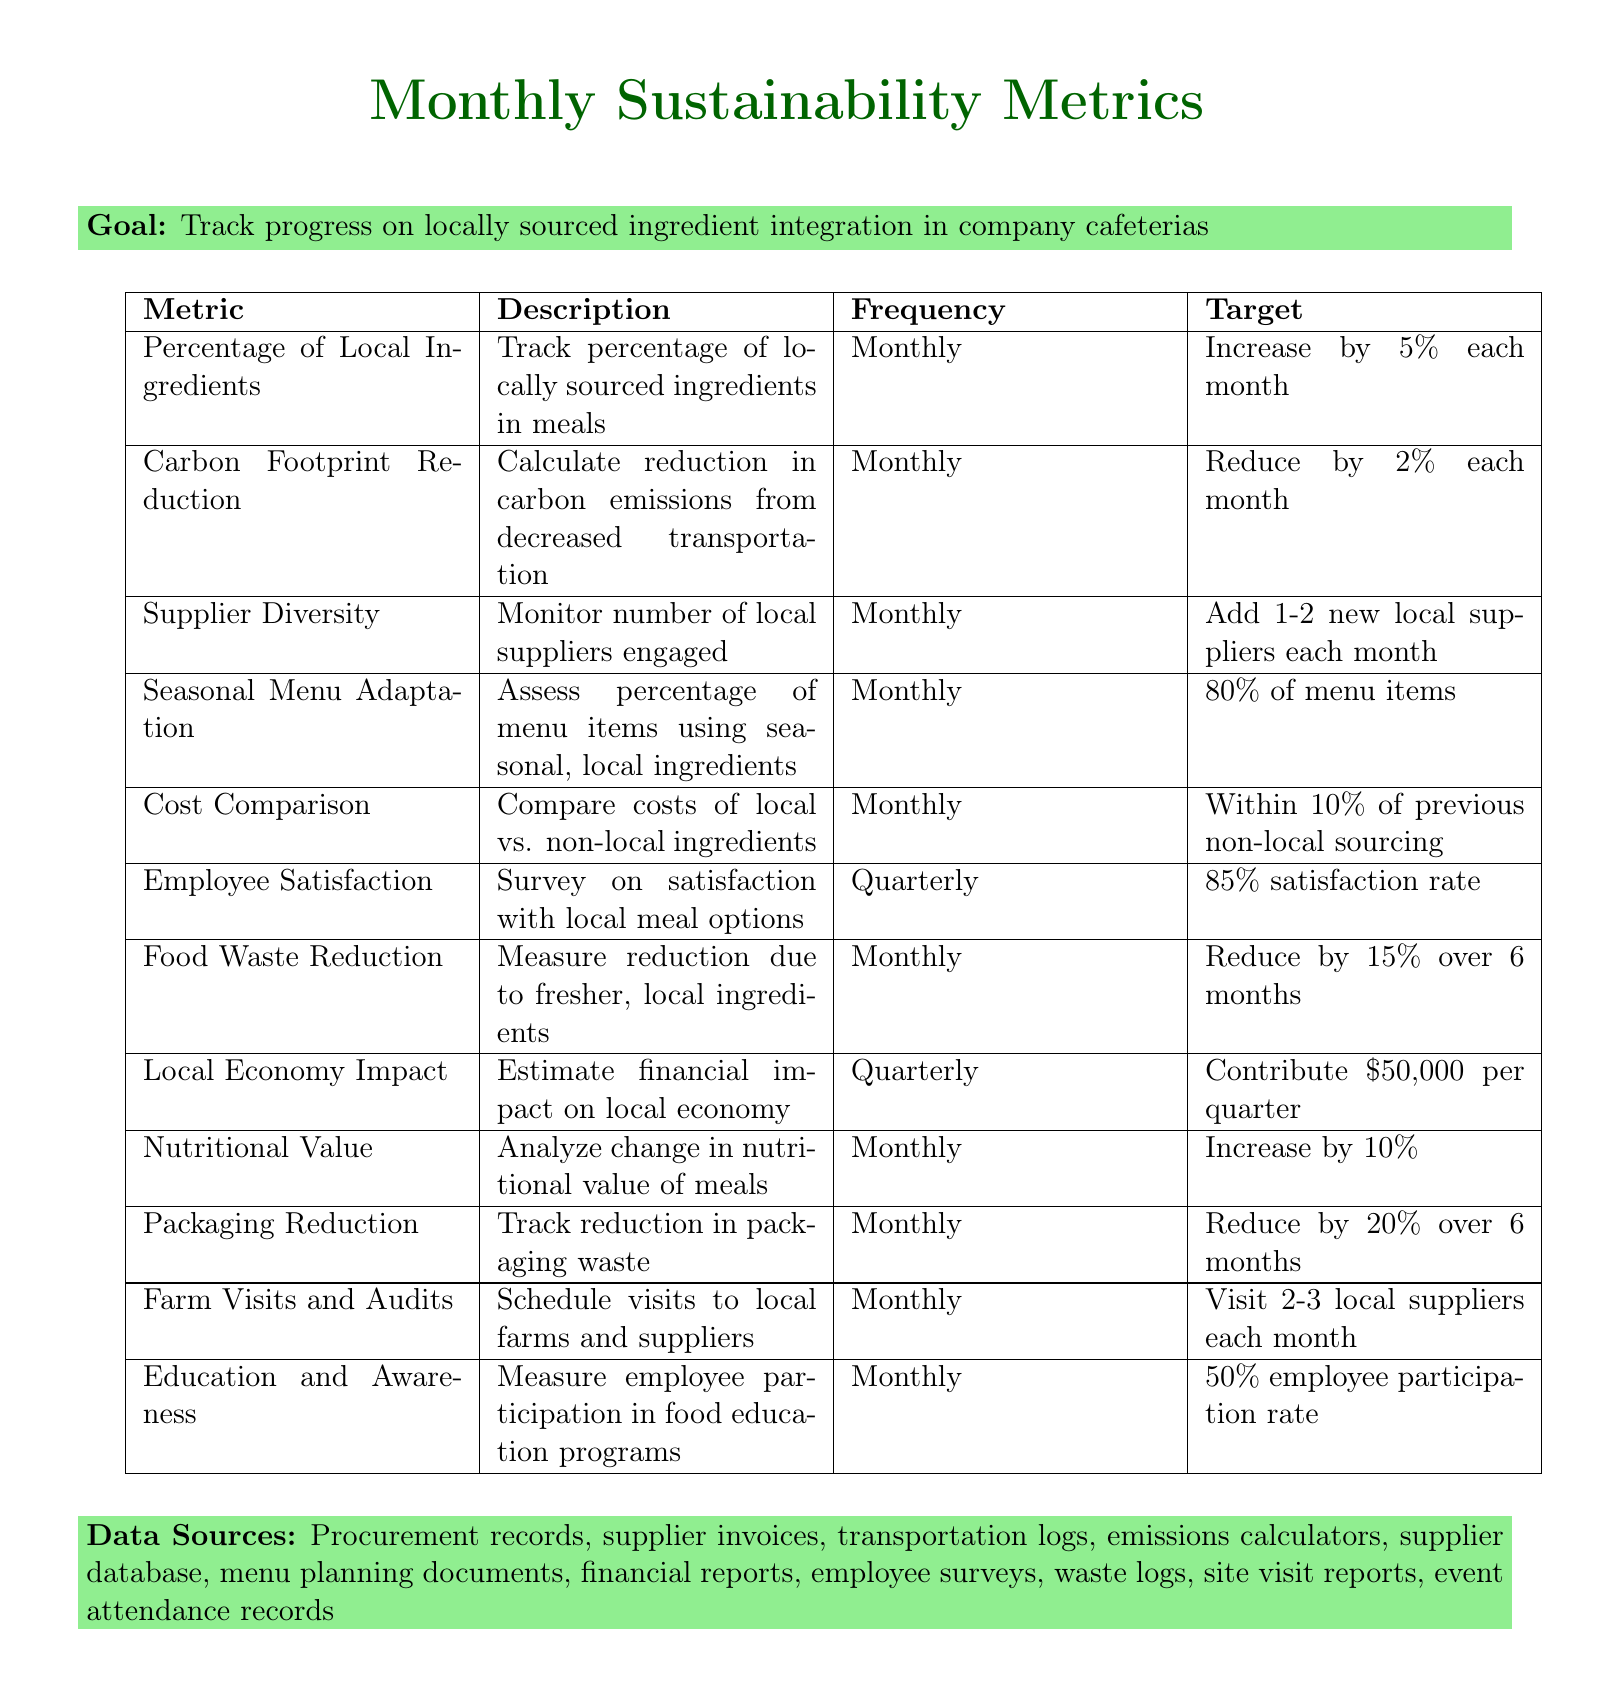What is the target increase for local ingredients? The target is an increase of 5% each month for the percentage of locally sourced ingredients used in cafeteria meals.
Answer: 5% How often is the Carbon Footprint Reduction metric tracked? The Carbon Footprint Reduction metric is tracked monthly according to the document.
Answer: Monthly What is the goal for Supplier Diversity each month? The goal is to add 1-2 new local suppliers each month as stated in the document.
Answer: 1-2 new local suppliers What percentage of menu items should use seasonal ingredients? The target for menu adaptation to use seasonal ingredients is 80%.
Answer: 80% How much should the cost of locally sourced ingredients remain within of non-local alternatives? The target is to maintain costs within 10% of previous non-local sourcing costs.
Answer: 10% What is the target reduction in food waste over 6 months? The target for food waste reduction is 15% over 6 months as mentioned in the document.
Answer: 15% How many local suppliers should be visited each month? The target is to visit 2-3 local suppliers each month according to the metrics tracking.
Answer: 2-3 local suppliers What percentage of employee participation is targeted in local food education programs? The document states a target of 50% employee participation rate in educational initiatives.
Answer: 50% What is the data source for re-evaluating the nutritional value? The document lists nutritional analysis reports as the source for analyzing nutritional value.
Answer: Nutritional analysis reports 